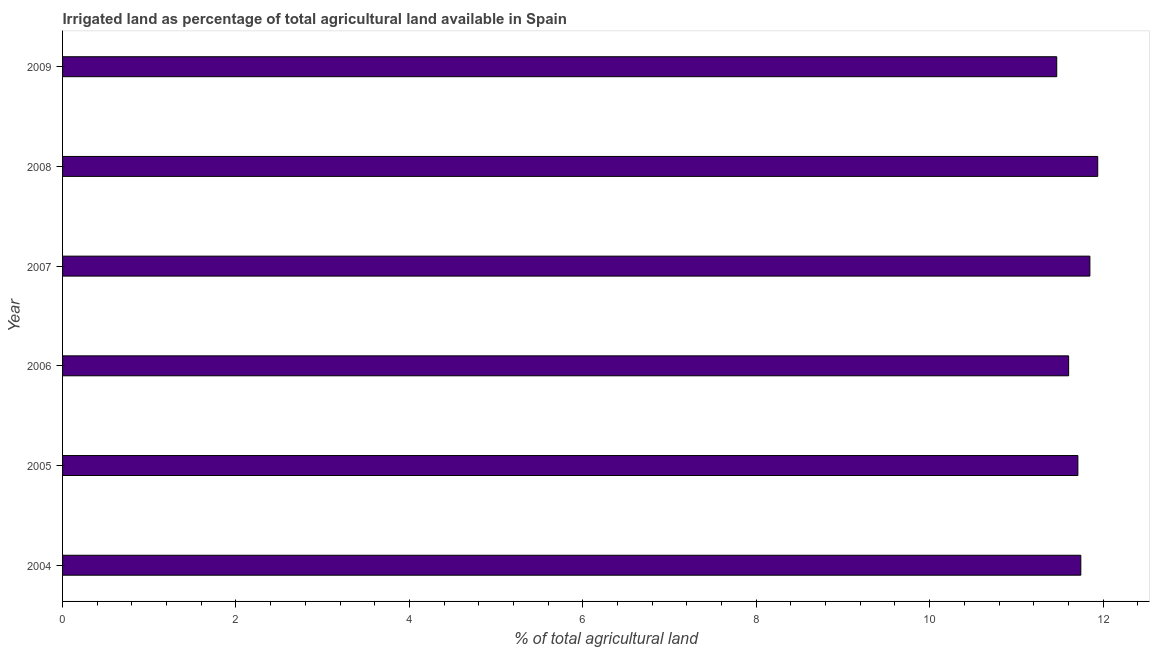Does the graph contain any zero values?
Your answer should be very brief. No. Does the graph contain grids?
Provide a succinct answer. No. What is the title of the graph?
Make the answer very short. Irrigated land as percentage of total agricultural land available in Spain. What is the label or title of the X-axis?
Offer a terse response. % of total agricultural land. What is the label or title of the Y-axis?
Your response must be concise. Year. What is the percentage of agricultural irrigated land in 2006?
Ensure brevity in your answer.  11.6. Across all years, what is the maximum percentage of agricultural irrigated land?
Provide a short and direct response. 11.94. Across all years, what is the minimum percentage of agricultural irrigated land?
Ensure brevity in your answer.  11.47. In which year was the percentage of agricultural irrigated land maximum?
Give a very brief answer. 2008. What is the sum of the percentage of agricultural irrigated land?
Provide a short and direct response. 70.31. What is the difference between the percentage of agricultural irrigated land in 2007 and 2008?
Provide a short and direct response. -0.09. What is the average percentage of agricultural irrigated land per year?
Give a very brief answer. 11.72. What is the median percentage of agricultural irrigated land?
Provide a short and direct response. 11.73. Do a majority of the years between 2004 and 2005 (inclusive) have percentage of agricultural irrigated land greater than 1.6 %?
Your response must be concise. Yes. What is the difference between the highest and the second highest percentage of agricultural irrigated land?
Your answer should be compact. 0.09. What is the difference between the highest and the lowest percentage of agricultural irrigated land?
Offer a terse response. 0.47. How many bars are there?
Provide a succinct answer. 6. Are all the bars in the graph horizontal?
Make the answer very short. Yes. How many years are there in the graph?
Ensure brevity in your answer.  6. What is the % of total agricultural land of 2004?
Keep it short and to the point. 11.74. What is the % of total agricultural land of 2005?
Provide a succinct answer. 11.71. What is the % of total agricultural land of 2006?
Your answer should be compact. 11.6. What is the % of total agricultural land of 2007?
Give a very brief answer. 11.85. What is the % of total agricultural land in 2008?
Offer a very short reply. 11.94. What is the % of total agricultural land in 2009?
Ensure brevity in your answer.  11.47. What is the difference between the % of total agricultural land in 2004 and 2005?
Keep it short and to the point. 0.03. What is the difference between the % of total agricultural land in 2004 and 2006?
Your answer should be very brief. 0.14. What is the difference between the % of total agricultural land in 2004 and 2007?
Offer a very short reply. -0.1. What is the difference between the % of total agricultural land in 2004 and 2008?
Offer a very short reply. -0.2. What is the difference between the % of total agricultural land in 2004 and 2009?
Your response must be concise. 0.28. What is the difference between the % of total agricultural land in 2005 and 2006?
Your answer should be very brief. 0.11. What is the difference between the % of total agricultural land in 2005 and 2007?
Make the answer very short. -0.14. What is the difference between the % of total agricultural land in 2005 and 2008?
Provide a short and direct response. -0.23. What is the difference between the % of total agricultural land in 2005 and 2009?
Keep it short and to the point. 0.24. What is the difference between the % of total agricultural land in 2006 and 2007?
Provide a succinct answer. -0.25. What is the difference between the % of total agricultural land in 2006 and 2008?
Your answer should be very brief. -0.34. What is the difference between the % of total agricultural land in 2006 and 2009?
Your answer should be compact. 0.14. What is the difference between the % of total agricultural land in 2007 and 2008?
Provide a short and direct response. -0.09. What is the difference between the % of total agricultural land in 2007 and 2009?
Give a very brief answer. 0.38. What is the difference between the % of total agricultural land in 2008 and 2009?
Keep it short and to the point. 0.47. What is the ratio of the % of total agricultural land in 2005 to that in 2006?
Offer a terse response. 1.01. What is the ratio of the % of total agricultural land in 2005 to that in 2008?
Provide a short and direct response. 0.98. What is the ratio of the % of total agricultural land in 2007 to that in 2008?
Your response must be concise. 0.99. What is the ratio of the % of total agricultural land in 2007 to that in 2009?
Your response must be concise. 1.03. What is the ratio of the % of total agricultural land in 2008 to that in 2009?
Offer a very short reply. 1.04. 